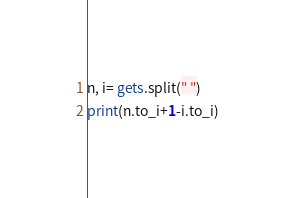Convert code to text. <code><loc_0><loc_0><loc_500><loc_500><_Ruby_>n, i= gets.split(" ")
print(n.to_i+1-i.to_i)</code> 